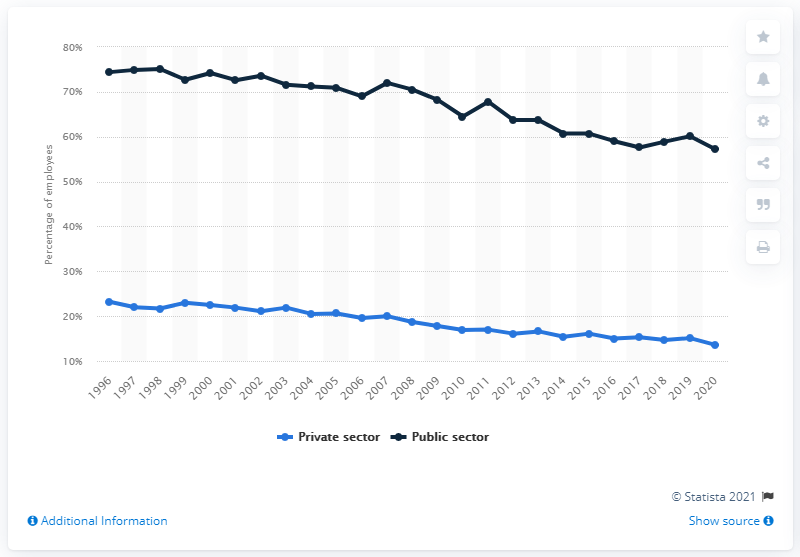Draw attention to some important aspects in this diagram. In 2020, 57.2% of employees in the public sector had their pay and conditions negotiated for them by a union. 